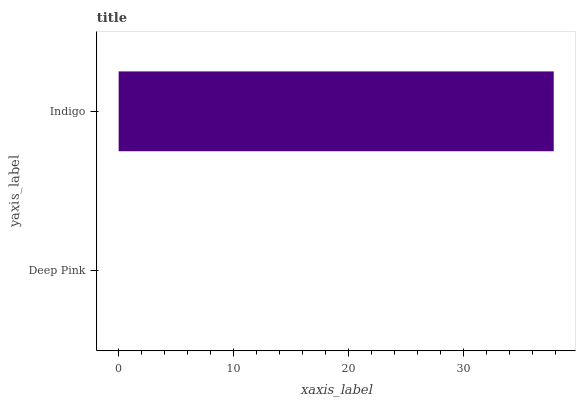Is Deep Pink the minimum?
Answer yes or no. Yes. Is Indigo the maximum?
Answer yes or no. Yes. Is Indigo the minimum?
Answer yes or no. No. Is Indigo greater than Deep Pink?
Answer yes or no. Yes. Is Deep Pink less than Indigo?
Answer yes or no. Yes. Is Deep Pink greater than Indigo?
Answer yes or no. No. Is Indigo less than Deep Pink?
Answer yes or no. No. Is Indigo the high median?
Answer yes or no. Yes. Is Deep Pink the low median?
Answer yes or no. Yes. Is Deep Pink the high median?
Answer yes or no. No. Is Indigo the low median?
Answer yes or no. No. 